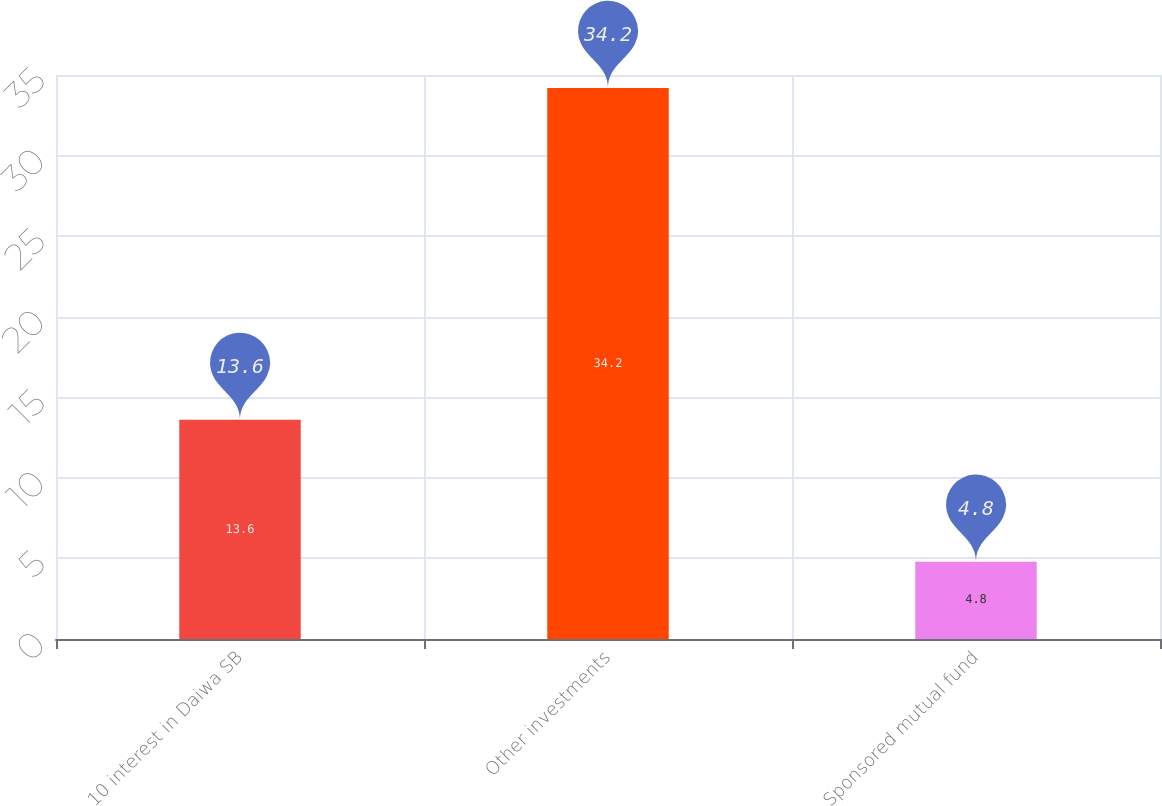Convert chart to OTSL. <chart><loc_0><loc_0><loc_500><loc_500><bar_chart><fcel>10 interest in Daiwa SB<fcel>Other investments<fcel>Sponsored mutual fund<nl><fcel>13.6<fcel>34.2<fcel>4.8<nl></chart> 